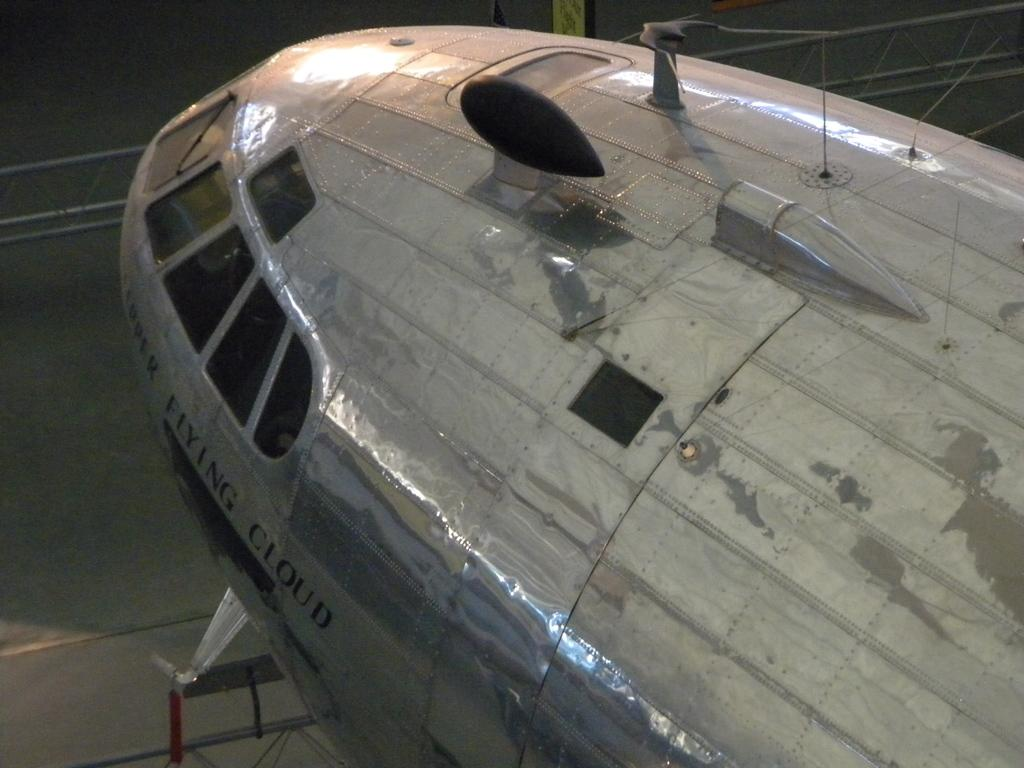<image>
Write a terse but informative summary of the picture. a plane cockpit is shown with FLYING CLOUD written on the side 